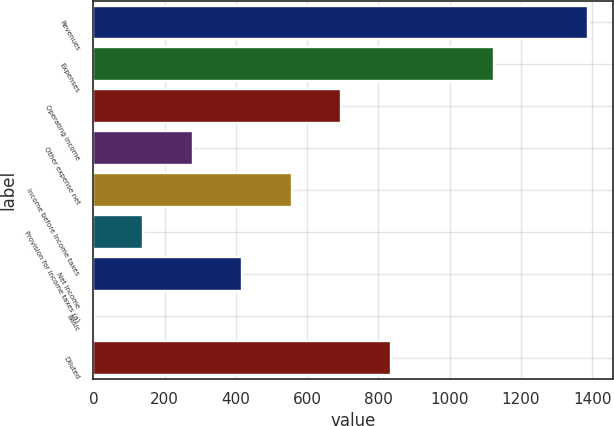Convert chart. <chart><loc_0><loc_0><loc_500><loc_500><bar_chart><fcel>Revenues<fcel>Expenses<fcel>Operating income<fcel>Other expense net<fcel>Income before income taxes<fcel>Provision for income taxes (a)<fcel>Net income<fcel>Basic<fcel>Diluted<nl><fcel>1389.4<fcel>1124.5<fcel>694.91<fcel>278.24<fcel>556.02<fcel>139.35<fcel>417.13<fcel>0.46<fcel>833.8<nl></chart> 